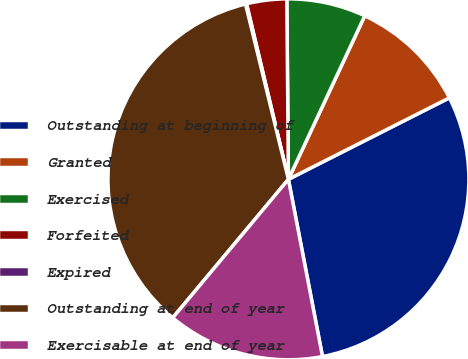<chart> <loc_0><loc_0><loc_500><loc_500><pie_chart><fcel>Outstanding at beginning of<fcel>Granted<fcel>Exercised<fcel>Forfeited<fcel>Expired<fcel>Outstanding at end of year<fcel>Exercisable at end of year<nl><fcel>29.43%<fcel>10.59%<fcel>7.09%<fcel>3.59%<fcel>0.09%<fcel>35.1%<fcel>14.1%<nl></chart> 